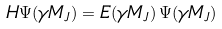Convert formula to latex. <formula><loc_0><loc_0><loc_500><loc_500>H \Psi ( \gamma M _ { J } ) = E ( \gamma M _ { J } ) \, \Psi ( \gamma M _ { J } )</formula> 